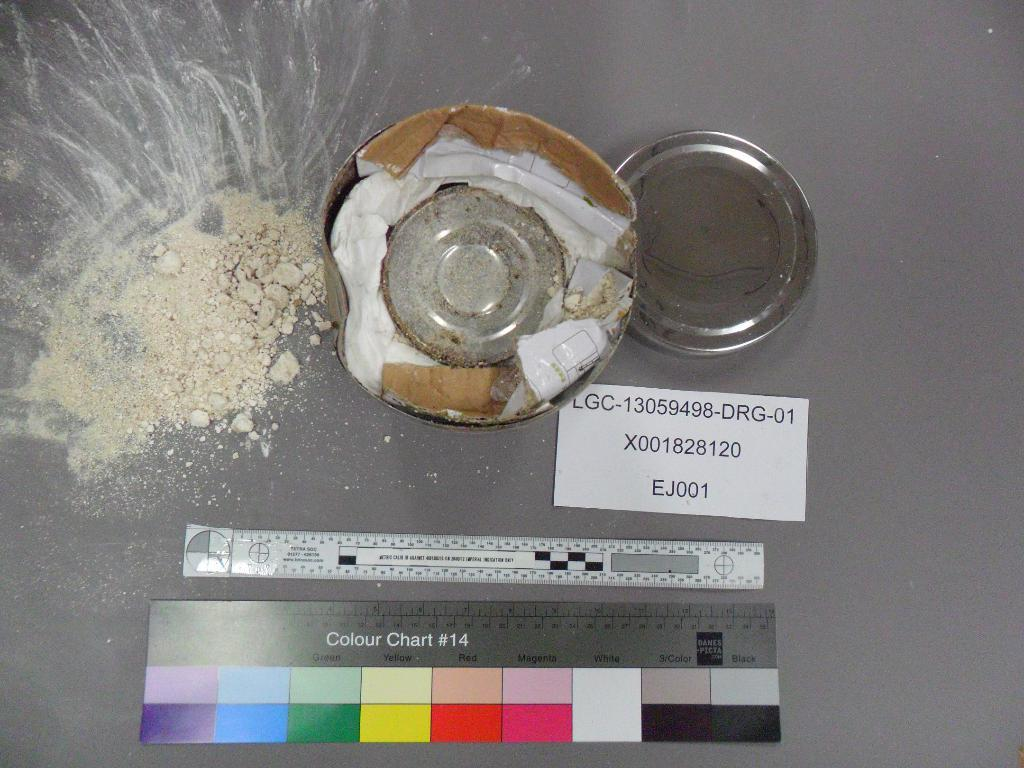<image>
Provide a brief description of the given image. Debris with a Colour Chart #14 below it and white label with the identification EJ001. 